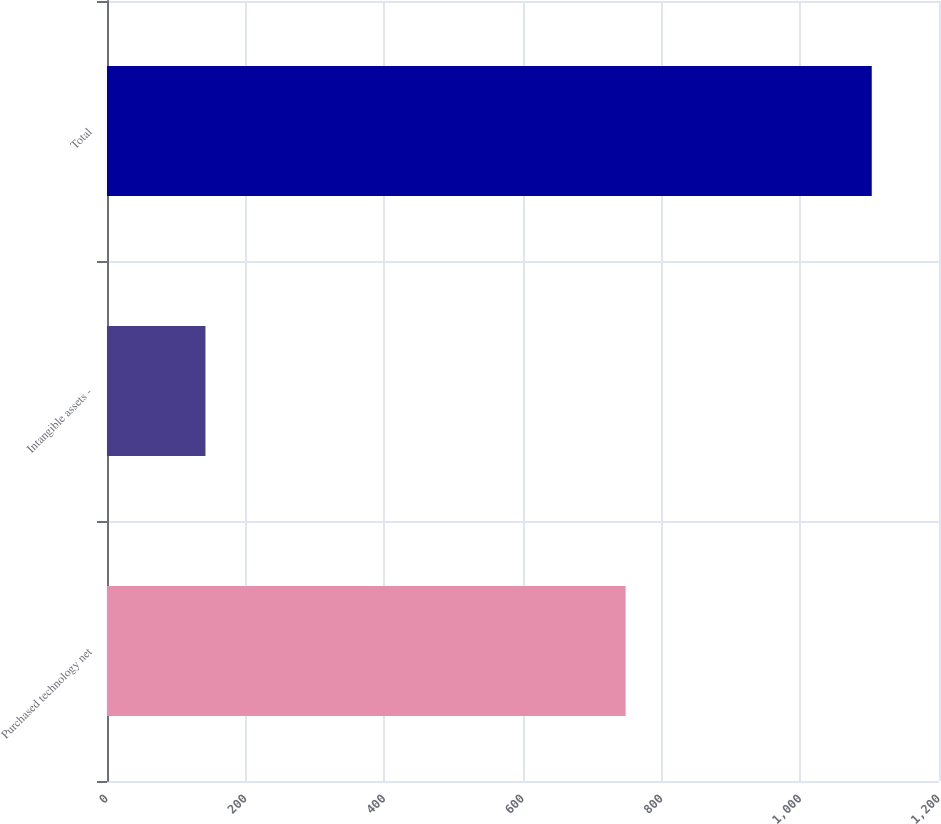Convert chart to OTSL. <chart><loc_0><loc_0><loc_500><loc_500><bar_chart><fcel>Purchased technology net<fcel>Intangible assets -<fcel>Total<nl><fcel>748<fcel>142<fcel>1103<nl></chart> 